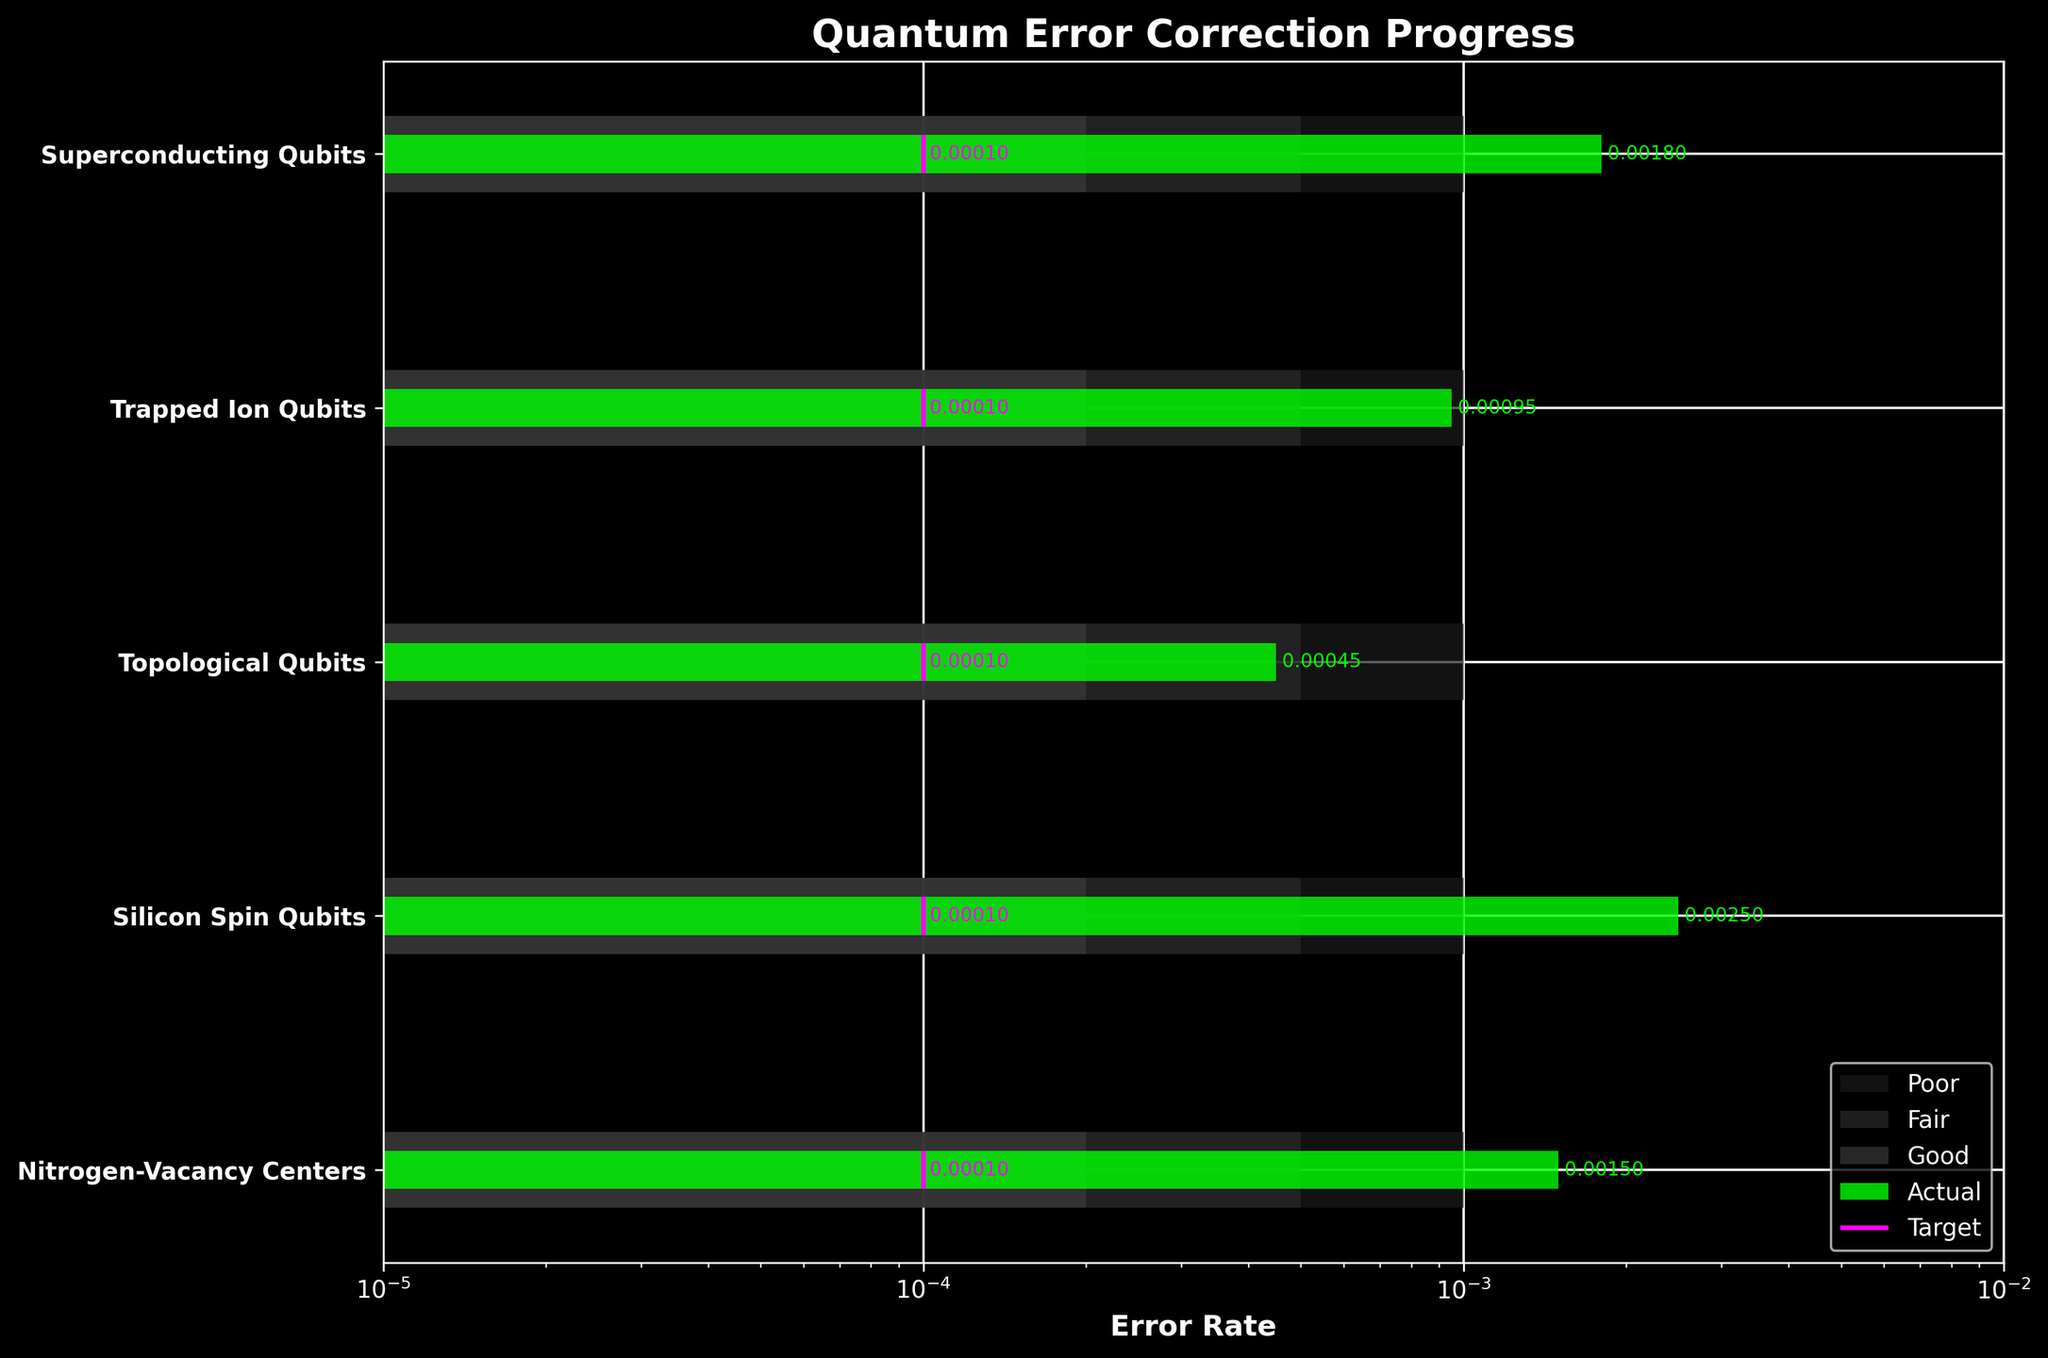How many qubit types are represented in the figure? To determine the number of qubit types, count the distinct categories listed on the vertical axis of the bullet chart. There are five categories labeled: Superconducting Qubits, Trapped Ion Qubits, Topological Qubits, Silicon Spin Qubits, and Nitrogen-Vacancy Centers.
Answer: 5 Which qubit type has the highest actual error rate? Observe the horizontal bars for the actual values and identify which one extends the furthest on the logarithmic scale. Silicon Spin Qubits have the highest actual error rate.
Answer: Silicon Spin Qubits What is the target error rate for all qubit types? Check the vertical lines marked as targets for each qubit type. Each target line is positioned at the same value.
Answer: 0.0001 How many qubit types have achieved an actual error rate better than the second range (fair)? Consider the position of the actual error rates relative to the specified ranges: Good, Fair, and Poor. The second range boundary for all qubit types is 0.0005. Superconducting Qubits, Trapped Ion Qubits, Topological Qubits, and Nitrogen-Vacancy Centers are all within this range.
Answer: 4 Which qubit type comes closest to its target error rate? Compare the distances between the actual values and the target lines. Topological Qubits have the actual error rate closest to the target.
Answer: Topological Qubits What is the difference between the error rate of Superconducting Qubits and Trapped Ion Qubits? Find the actual error rates for both qubit types and subtract the smaller value from the larger one: 0.0018 (Superconducting Qubits) - 0.00095 (Trapped Ion Qubits).
Answer: 0.00085 In the context of error correction progress, which qubit type is in the poorest category? Identify the actual error rates and locate which of them fall into the lightest color range, "Poor," wherein the range exceeds the threshold of 0.001. Silicon Spin Qubits fall into this category.
Answer: Silicon Spin Qubits How do Superconducting Qubits fare in terms of the defined "Good" range? Compare the actual error rate of Superconducting Qubits to the "Good" range boundary at 0.0002. At 0.0018, they fall well outside of the "Good" range.
Answer: Outside Good range Which two qubits have their actual error rates closest to one another, and what is the actual error rate difference between them? Calculate the differences between the actual error rates for each pair of qubit types and identify the pair with the smallest difference. For Trapped Ion Qubits and Topological Qubits, the difference is 0.00095 - 0.00045.
Answer: Trapped Ion Qubits and Topological Qubits; 0.0005 